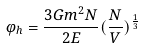Convert formula to latex. <formula><loc_0><loc_0><loc_500><loc_500>\varphi _ { h } = \frac { 3 G m ^ { 2 } N } { 2 E } ( \frac { N } { V } ) ^ { \frac { 1 } { 3 } }</formula> 